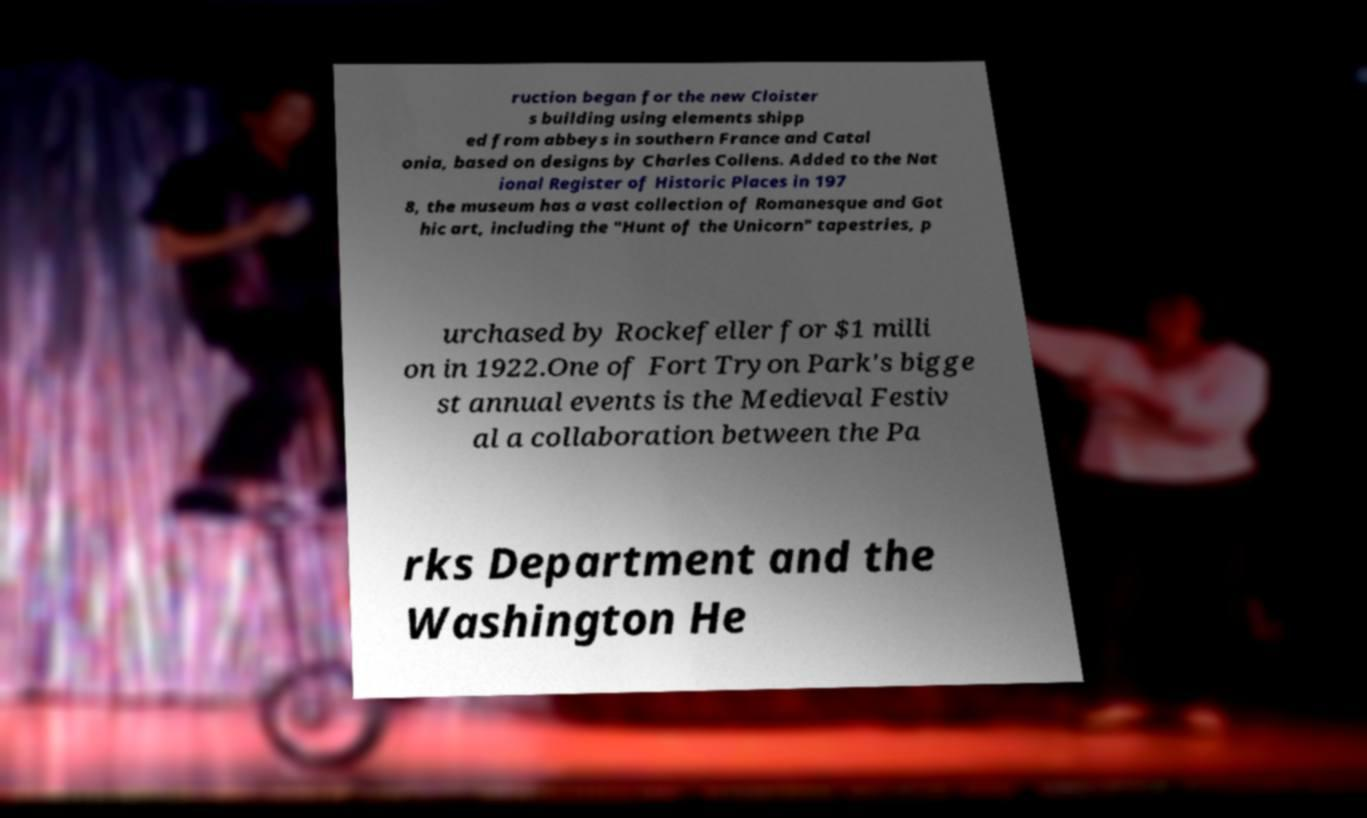Can you read and provide the text displayed in the image?This photo seems to have some interesting text. Can you extract and type it out for me? ruction began for the new Cloister s building using elements shipp ed from abbeys in southern France and Catal onia, based on designs by Charles Collens. Added to the Nat ional Register of Historic Places in 197 8, the museum has a vast collection of Romanesque and Got hic art, including the "Hunt of the Unicorn" tapestries, p urchased by Rockefeller for $1 milli on in 1922.One of Fort Tryon Park's bigge st annual events is the Medieval Festiv al a collaboration between the Pa rks Department and the Washington He 